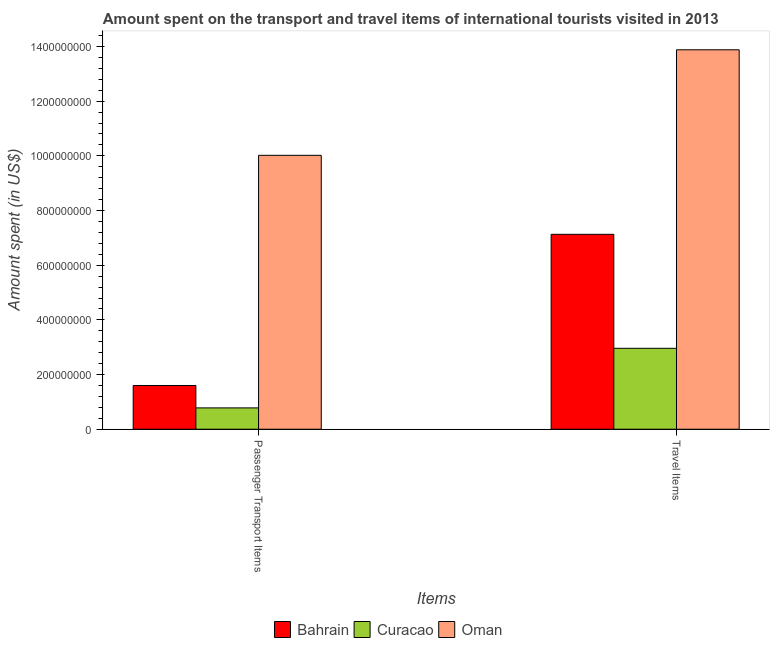How many different coloured bars are there?
Ensure brevity in your answer.  3. How many bars are there on the 2nd tick from the left?
Your response must be concise. 3. What is the label of the 1st group of bars from the left?
Your answer should be compact. Passenger Transport Items. What is the amount spent in travel items in Curacao?
Ensure brevity in your answer.  2.96e+08. Across all countries, what is the maximum amount spent on passenger transport items?
Give a very brief answer. 1.00e+09. Across all countries, what is the minimum amount spent on passenger transport items?
Ensure brevity in your answer.  7.80e+07. In which country was the amount spent on passenger transport items maximum?
Your answer should be compact. Oman. In which country was the amount spent in travel items minimum?
Your answer should be compact. Curacao. What is the total amount spent on passenger transport items in the graph?
Your answer should be very brief. 1.24e+09. What is the difference between the amount spent on passenger transport items in Bahrain and that in Oman?
Provide a succinct answer. -8.42e+08. What is the difference between the amount spent in travel items in Curacao and the amount spent on passenger transport items in Oman?
Offer a very short reply. -7.06e+08. What is the average amount spent in travel items per country?
Ensure brevity in your answer.  7.99e+08. What is the difference between the amount spent in travel items and amount spent on passenger transport items in Oman?
Offer a very short reply. 3.86e+08. What is the ratio of the amount spent in travel items in Oman to that in Curacao?
Offer a very short reply. 4.69. Is the amount spent on passenger transport items in Bahrain less than that in Curacao?
Keep it short and to the point. No. What does the 1st bar from the left in Travel Items represents?
Your response must be concise. Bahrain. What does the 3rd bar from the right in Travel Items represents?
Keep it short and to the point. Bahrain. How many bars are there?
Offer a very short reply. 6. How many countries are there in the graph?
Provide a short and direct response. 3. Does the graph contain any zero values?
Your answer should be compact. No. How many legend labels are there?
Your answer should be compact. 3. How are the legend labels stacked?
Your answer should be compact. Horizontal. What is the title of the graph?
Your answer should be very brief. Amount spent on the transport and travel items of international tourists visited in 2013. What is the label or title of the X-axis?
Provide a short and direct response. Items. What is the label or title of the Y-axis?
Give a very brief answer. Amount spent (in US$). What is the Amount spent (in US$) in Bahrain in Passenger Transport Items?
Ensure brevity in your answer.  1.60e+08. What is the Amount spent (in US$) in Curacao in Passenger Transport Items?
Your answer should be very brief. 7.80e+07. What is the Amount spent (in US$) of Oman in Passenger Transport Items?
Your answer should be very brief. 1.00e+09. What is the Amount spent (in US$) of Bahrain in Travel Items?
Offer a terse response. 7.13e+08. What is the Amount spent (in US$) in Curacao in Travel Items?
Give a very brief answer. 2.96e+08. What is the Amount spent (in US$) in Oman in Travel Items?
Your answer should be compact. 1.39e+09. Across all Items, what is the maximum Amount spent (in US$) in Bahrain?
Offer a terse response. 7.13e+08. Across all Items, what is the maximum Amount spent (in US$) of Curacao?
Offer a very short reply. 2.96e+08. Across all Items, what is the maximum Amount spent (in US$) in Oman?
Your response must be concise. 1.39e+09. Across all Items, what is the minimum Amount spent (in US$) of Bahrain?
Your response must be concise. 1.60e+08. Across all Items, what is the minimum Amount spent (in US$) of Curacao?
Make the answer very short. 7.80e+07. Across all Items, what is the minimum Amount spent (in US$) of Oman?
Your answer should be compact. 1.00e+09. What is the total Amount spent (in US$) of Bahrain in the graph?
Offer a terse response. 8.73e+08. What is the total Amount spent (in US$) of Curacao in the graph?
Keep it short and to the point. 3.74e+08. What is the total Amount spent (in US$) in Oman in the graph?
Make the answer very short. 2.39e+09. What is the difference between the Amount spent (in US$) of Bahrain in Passenger Transport Items and that in Travel Items?
Your response must be concise. -5.53e+08. What is the difference between the Amount spent (in US$) of Curacao in Passenger Transport Items and that in Travel Items?
Keep it short and to the point. -2.18e+08. What is the difference between the Amount spent (in US$) of Oman in Passenger Transport Items and that in Travel Items?
Offer a very short reply. -3.86e+08. What is the difference between the Amount spent (in US$) in Bahrain in Passenger Transport Items and the Amount spent (in US$) in Curacao in Travel Items?
Give a very brief answer. -1.36e+08. What is the difference between the Amount spent (in US$) of Bahrain in Passenger Transport Items and the Amount spent (in US$) of Oman in Travel Items?
Offer a terse response. -1.23e+09. What is the difference between the Amount spent (in US$) of Curacao in Passenger Transport Items and the Amount spent (in US$) of Oman in Travel Items?
Your answer should be compact. -1.31e+09. What is the average Amount spent (in US$) in Bahrain per Items?
Provide a short and direct response. 4.36e+08. What is the average Amount spent (in US$) of Curacao per Items?
Your response must be concise. 1.87e+08. What is the average Amount spent (in US$) of Oman per Items?
Make the answer very short. 1.20e+09. What is the difference between the Amount spent (in US$) in Bahrain and Amount spent (in US$) in Curacao in Passenger Transport Items?
Your answer should be compact. 8.20e+07. What is the difference between the Amount spent (in US$) in Bahrain and Amount spent (in US$) in Oman in Passenger Transport Items?
Your answer should be compact. -8.42e+08. What is the difference between the Amount spent (in US$) in Curacao and Amount spent (in US$) in Oman in Passenger Transport Items?
Offer a very short reply. -9.24e+08. What is the difference between the Amount spent (in US$) of Bahrain and Amount spent (in US$) of Curacao in Travel Items?
Your response must be concise. 4.17e+08. What is the difference between the Amount spent (in US$) in Bahrain and Amount spent (in US$) in Oman in Travel Items?
Give a very brief answer. -6.75e+08. What is the difference between the Amount spent (in US$) of Curacao and Amount spent (in US$) of Oman in Travel Items?
Your response must be concise. -1.09e+09. What is the ratio of the Amount spent (in US$) of Bahrain in Passenger Transport Items to that in Travel Items?
Offer a terse response. 0.22. What is the ratio of the Amount spent (in US$) of Curacao in Passenger Transport Items to that in Travel Items?
Your response must be concise. 0.26. What is the ratio of the Amount spent (in US$) in Oman in Passenger Transport Items to that in Travel Items?
Make the answer very short. 0.72. What is the difference between the highest and the second highest Amount spent (in US$) of Bahrain?
Provide a short and direct response. 5.53e+08. What is the difference between the highest and the second highest Amount spent (in US$) of Curacao?
Keep it short and to the point. 2.18e+08. What is the difference between the highest and the second highest Amount spent (in US$) of Oman?
Provide a short and direct response. 3.86e+08. What is the difference between the highest and the lowest Amount spent (in US$) of Bahrain?
Your response must be concise. 5.53e+08. What is the difference between the highest and the lowest Amount spent (in US$) in Curacao?
Give a very brief answer. 2.18e+08. What is the difference between the highest and the lowest Amount spent (in US$) in Oman?
Your answer should be compact. 3.86e+08. 